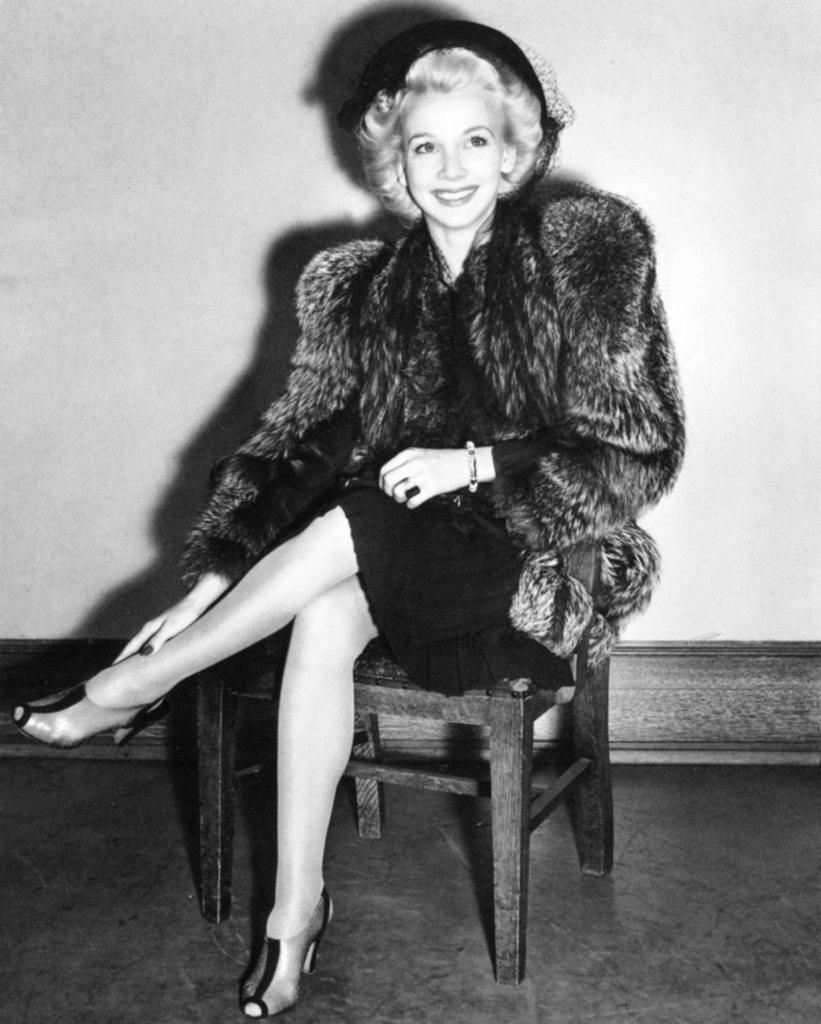Who is present in the image? There is a woman in the image. What is the woman doing in the image? The woman is sitting on a chair. What expression does the woman have in the image? The woman is smiling. What accessory is the woman wearing in the image? The woman is wearing a hat. How many babies are crawling on the floor in the image? There are no babies present in the image; it only features a woman sitting on a chair. What type of lace can be seen on the woman's clothing in the image? There is no lace visible on the woman's clothing in the image. 